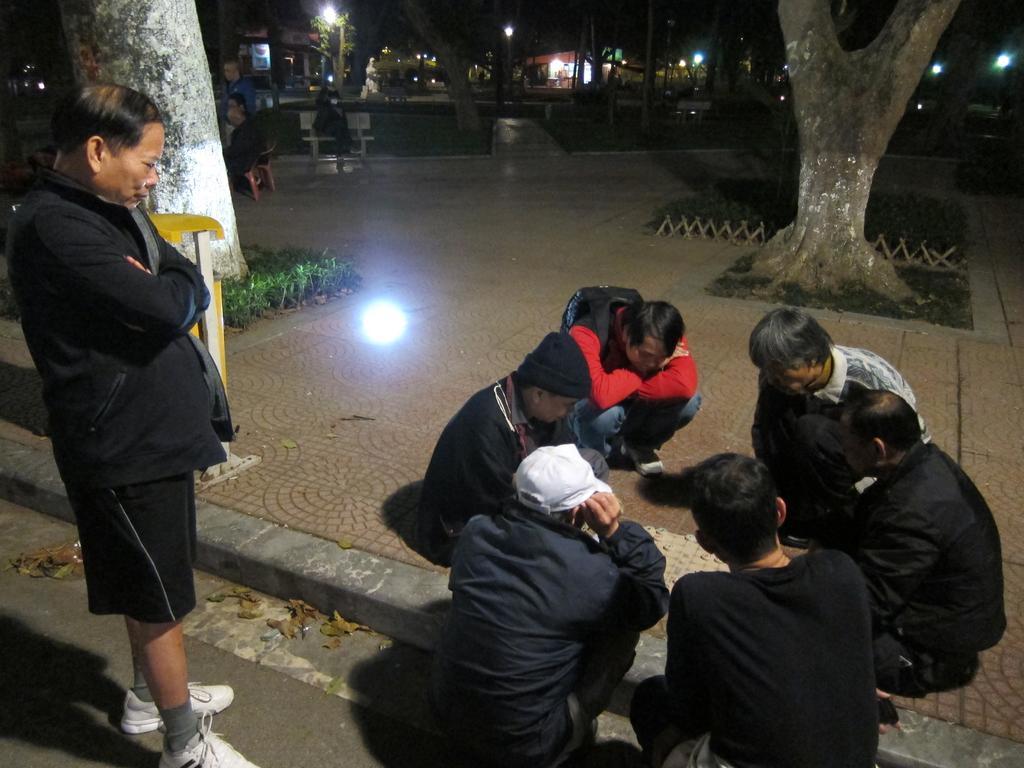Please provide a concise description of this image. This image is taken outdoors. At the bottom of the image there is a road. On the left side of the image a man is standing on the road and there is a tree and a few plants. On the right side of the image a few men are in a squatting position on the sidewalk and there is a tree. In the background there are a few trees, poles with street lights and a person is sitting on the bench. There are a few people. 